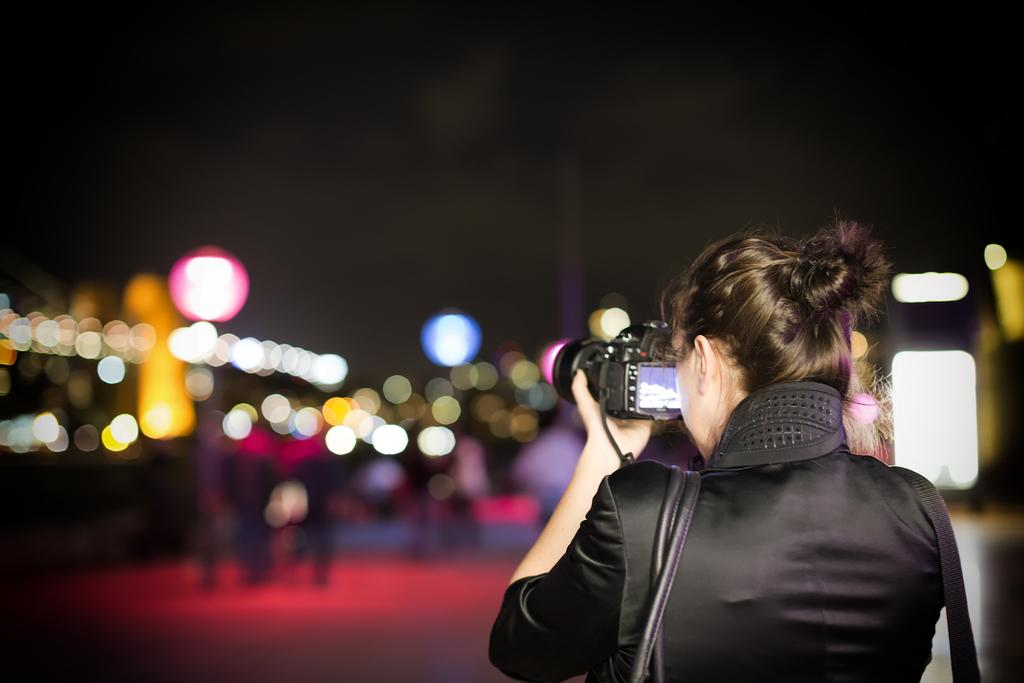Who is the main subject in the image? There is a woman in the image. What is the woman holding in the image? The woman is holding a camera. What else can be seen that the woman is wearing? The woman is wearing a bag. What type of monkey can be seen sitting on the woman's shoulder in the image? There is no monkey present in the image; the woman is holding a camera and wearing a bag. 